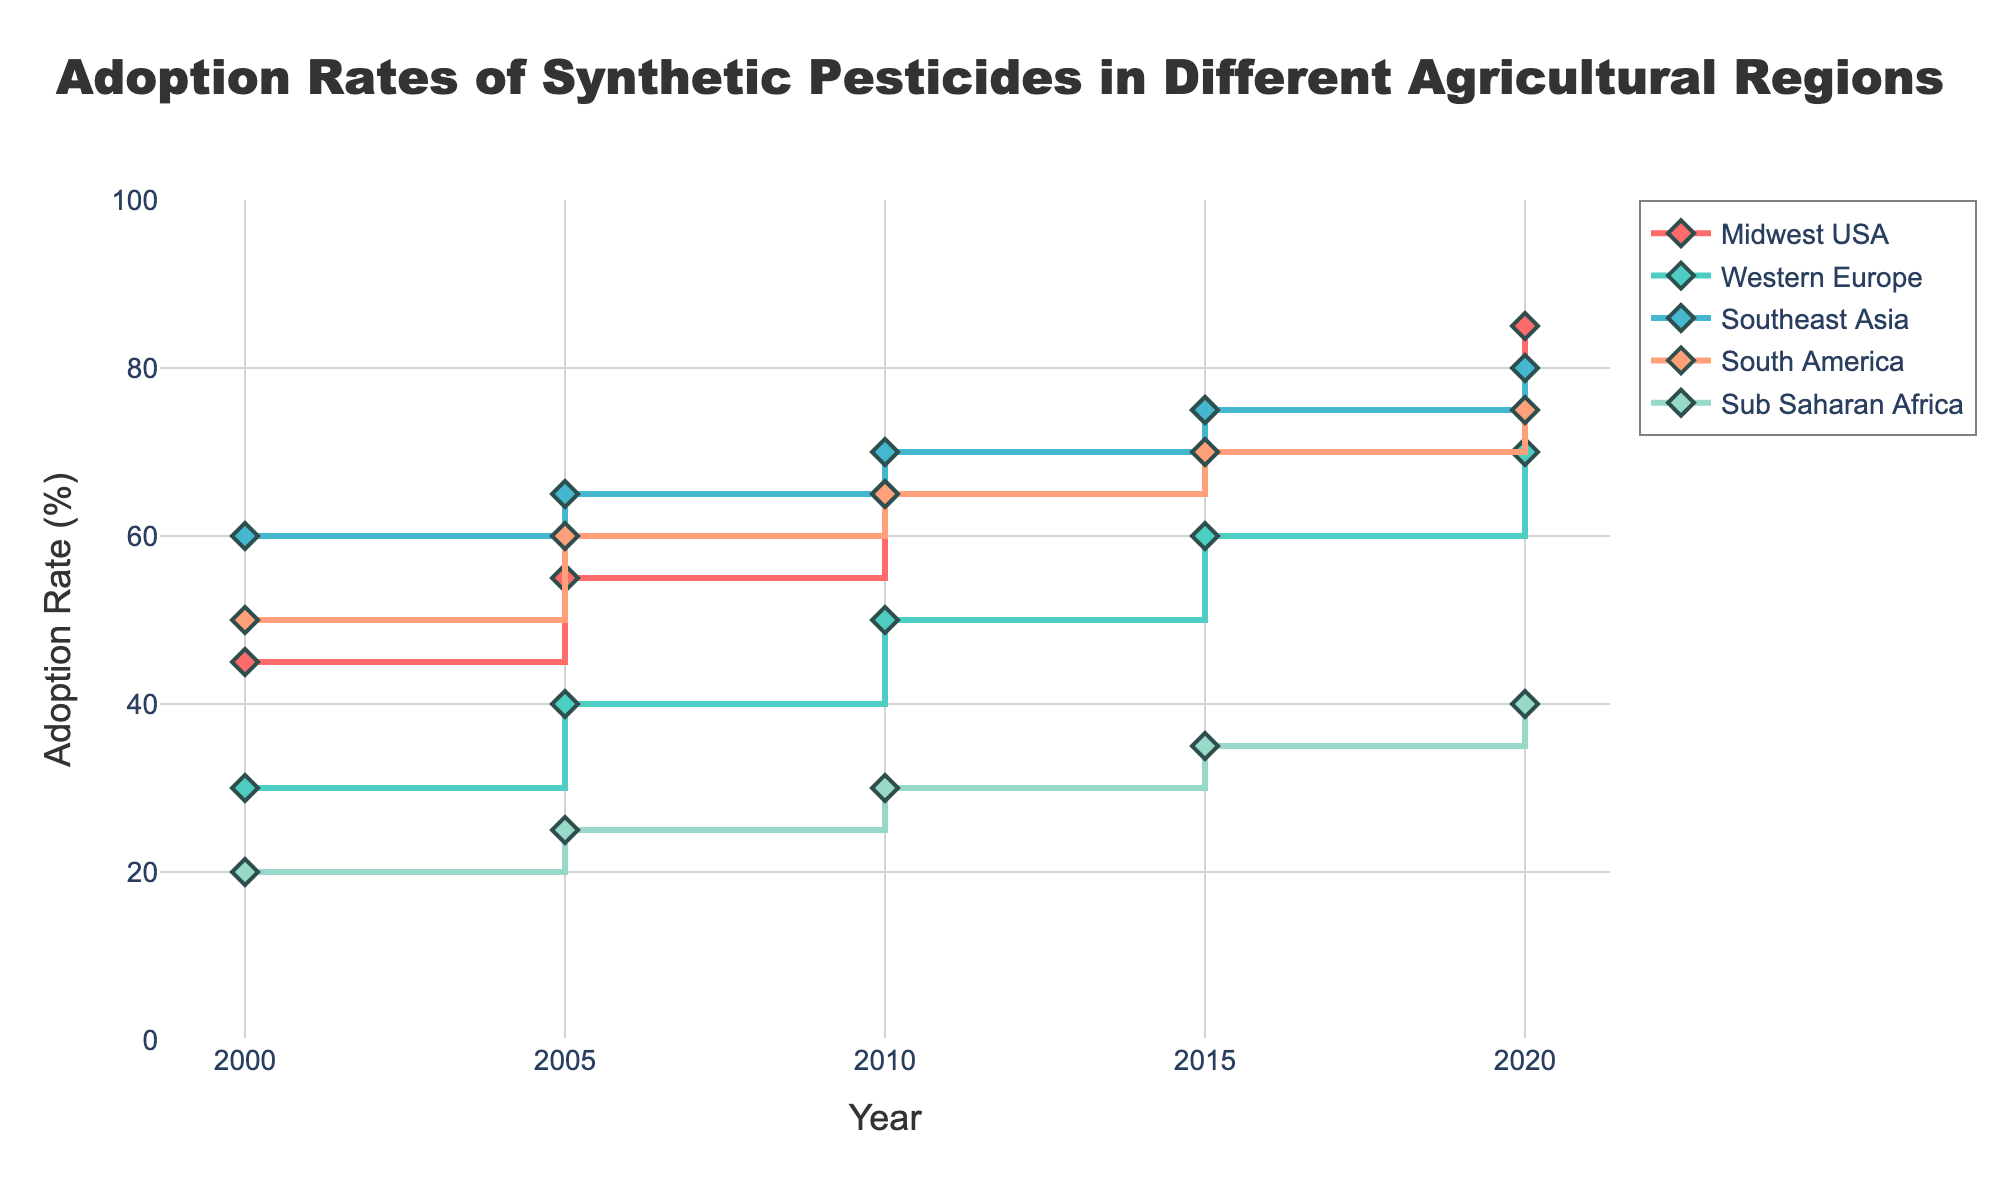What is the title of the stair plot? The title is prominently displayed at the top of the plot.
Answer: Adoption Rates of Synthetic Pesticides in Different Agricultural Regions What is the adoption rate of synthetic pesticides in the Midwest USA in 2020? Locate the line corresponding to Midwest USA, follow it to the year 2020, and read the adoption rate on the y-axis.
Answer: 85% Which region had the lowest adoption rate of synthetic pesticides in 2000? Look at the points corresponding to the year 2000 for all regions and identify the lowest value on the y-axis.
Answer: Sub-Saharan Africa How many regions have adoption rates displayed in the plot? Count the number of unique lines, each representing a different region.
Answer: Five By how much did the adoption rate increase in Western Europe from 2000 to 2020? Find the adoption rates for Western Europe in 2000 and 2020, then compute the difference (70% - 30%).
Answer: 40% Which region had the steepest increase in the adoption rate from 2000 to 2020? Compare the slopes of the lines for all regions from 2000 to 2020 and identify the one with the largest increase.
Answer: Midwest USA What is the average adoption rate of synthetic pesticides in Southeast Asia over all the years displayed? Add up the adoption rates for Southeast Asia from 2000 to 2020 and divide by the number of data points (60+65+70+75+80) / 5.
Answer: 70% Which region had the highest adoption rate in 2010, and what was the rate? Locate data points for the year 2010 across all lines and identify the highest value.
Answer: Southeast Asia, 70% Are there any regions where the adoption rate decreased at any point from 2000 to 2020? Examine each line to see if any region’s adoption rate drops at any point in the timeline.
Answer: No How does the adoption rate of South America in 2020 compare to that in Southeast Asia in 2010? Find the adoption rates and compare the two values.
Answer: 75% (South America) is greater than 70% (Southeast Asia) 